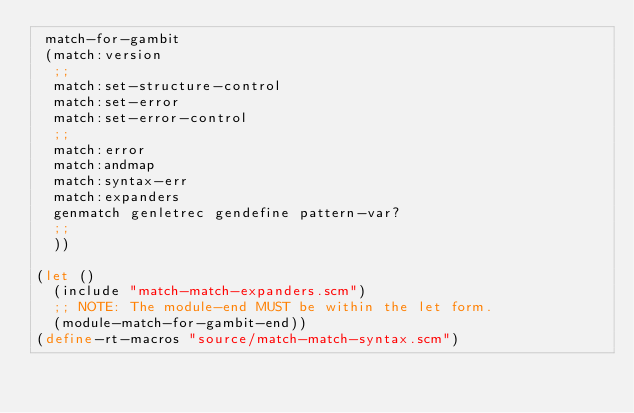Convert code to text. <code><loc_0><loc_0><loc_500><loc_500><_Scheme_> match-for-gambit
 (match:version
  ;;
  match:set-structure-control
  match:set-error
  match:set-error-control
  ;;
  match:error
  match:andmap
  match:syntax-err
  match:expanders
  genmatch genletrec gendefine pattern-var?
  ;;
  ))

(let ()
  (include "match-match-expanders.scm")
  ;; NOTE: The module-end MUST be within the let form.
  (module-match-for-gambit-end))
(define-rt-macros "source/match-match-syntax.scm")
</code> 